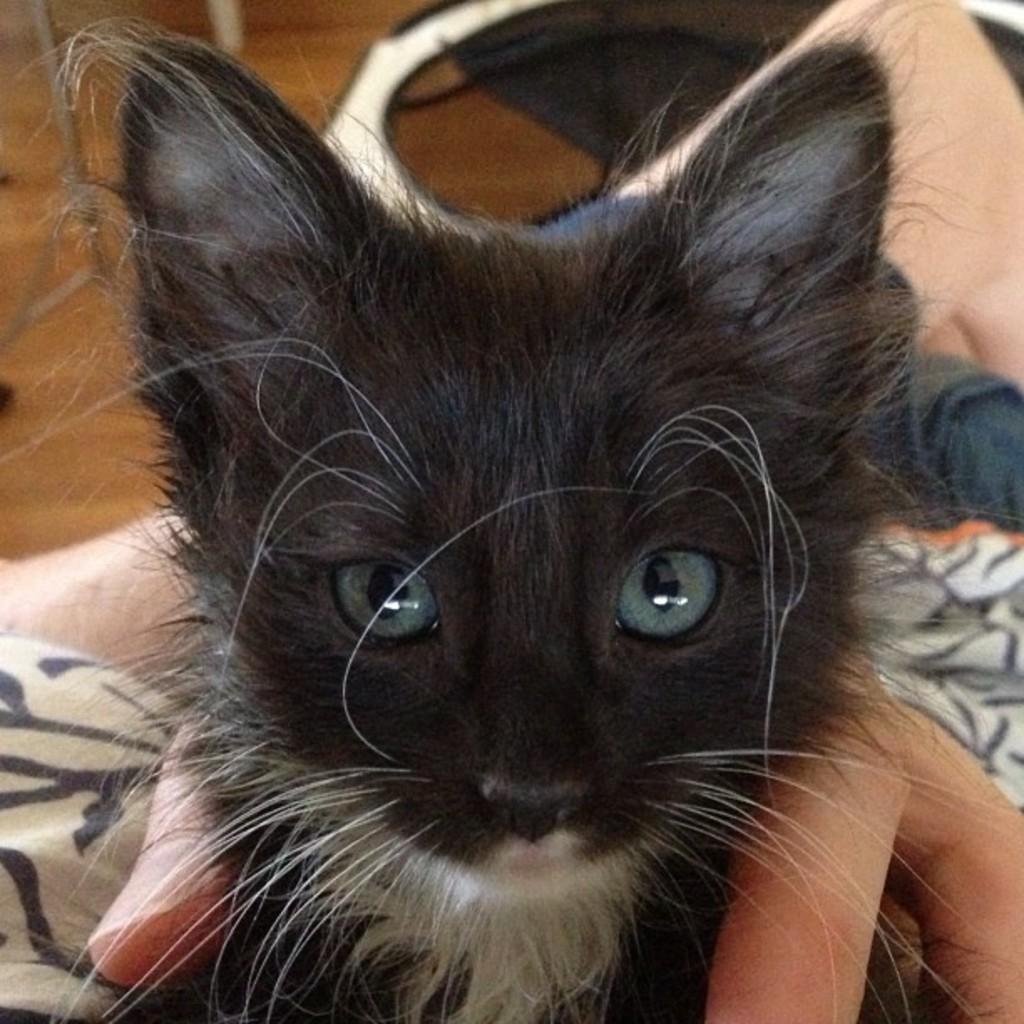What is the main subject of the image? There is a person in the image. What is the person holding in the image? The person is holding a black cat. What is the cat doing in the image? The cat is looking at the picture. What can be seen on the floor at the top of the image? There are objects on the floor at the top of the image. What type of popcorn is being served at the surprise party in the image? There is no mention of popcorn, a surprise party, or any party in the image. The image features a person holding a black cat, with the cat looking at the picture. 